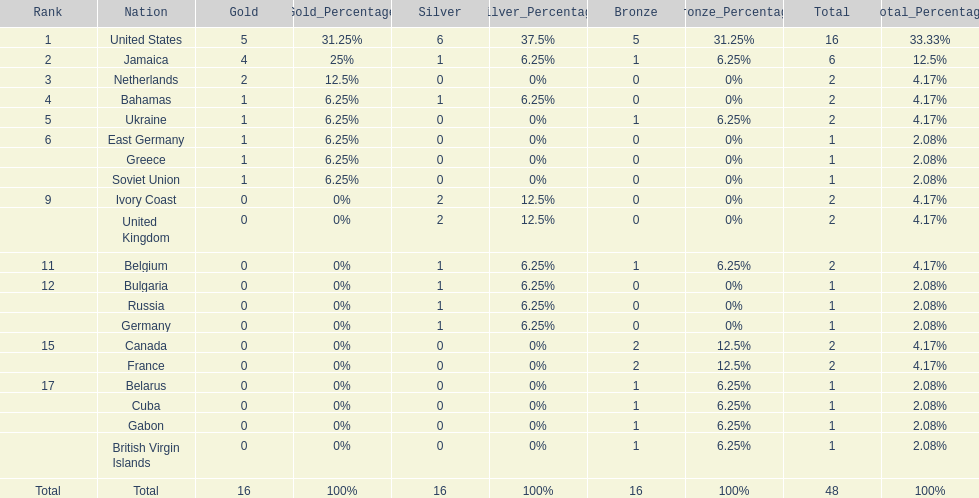How many nations won no gold medals? 12. 